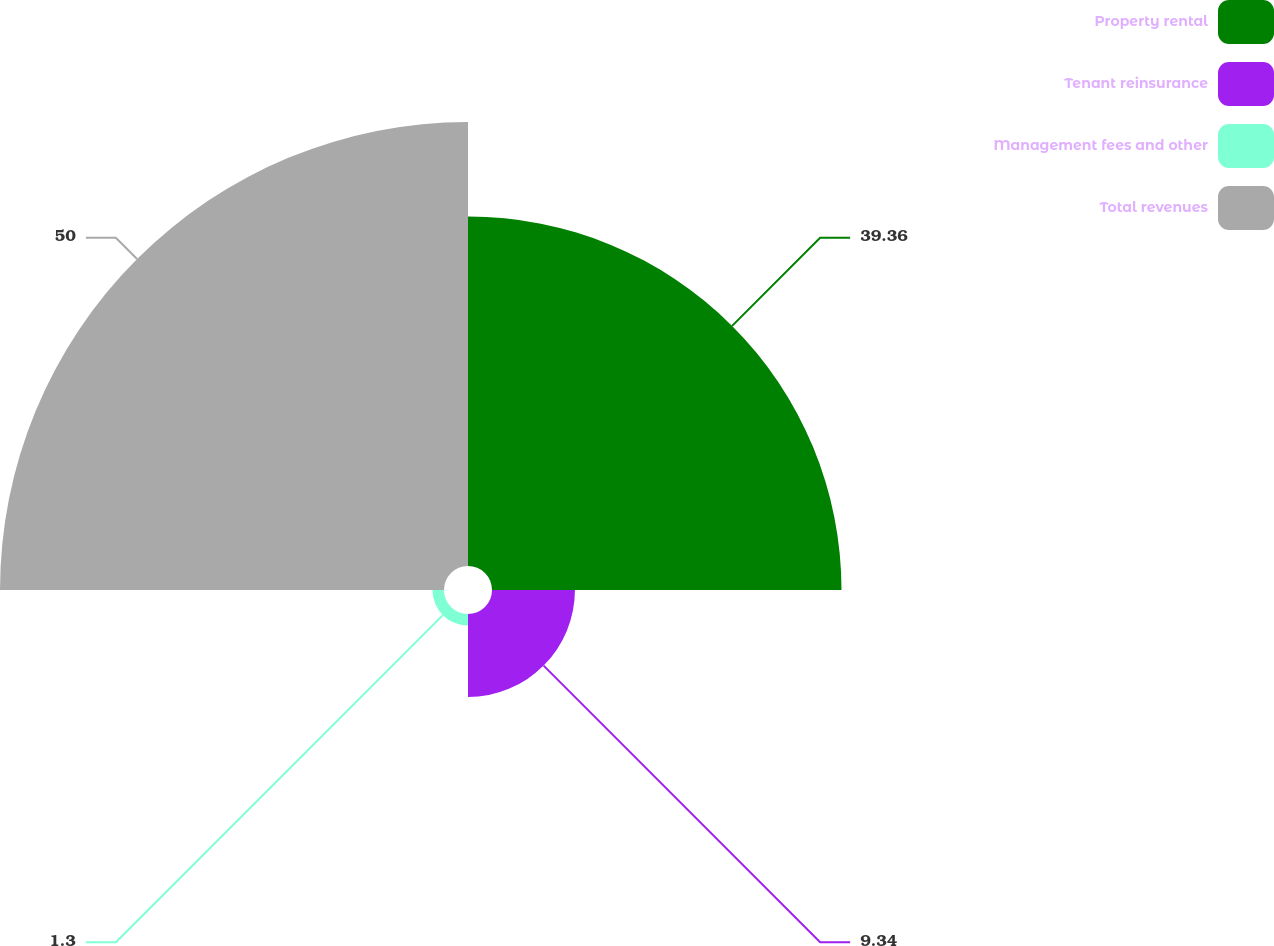Convert chart. <chart><loc_0><loc_0><loc_500><loc_500><pie_chart><fcel>Property rental<fcel>Tenant reinsurance<fcel>Management fees and other<fcel>Total revenues<nl><fcel>39.36%<fcel>9.34%<fcel>1.3%<fcel>50.0%<nl></chart> 